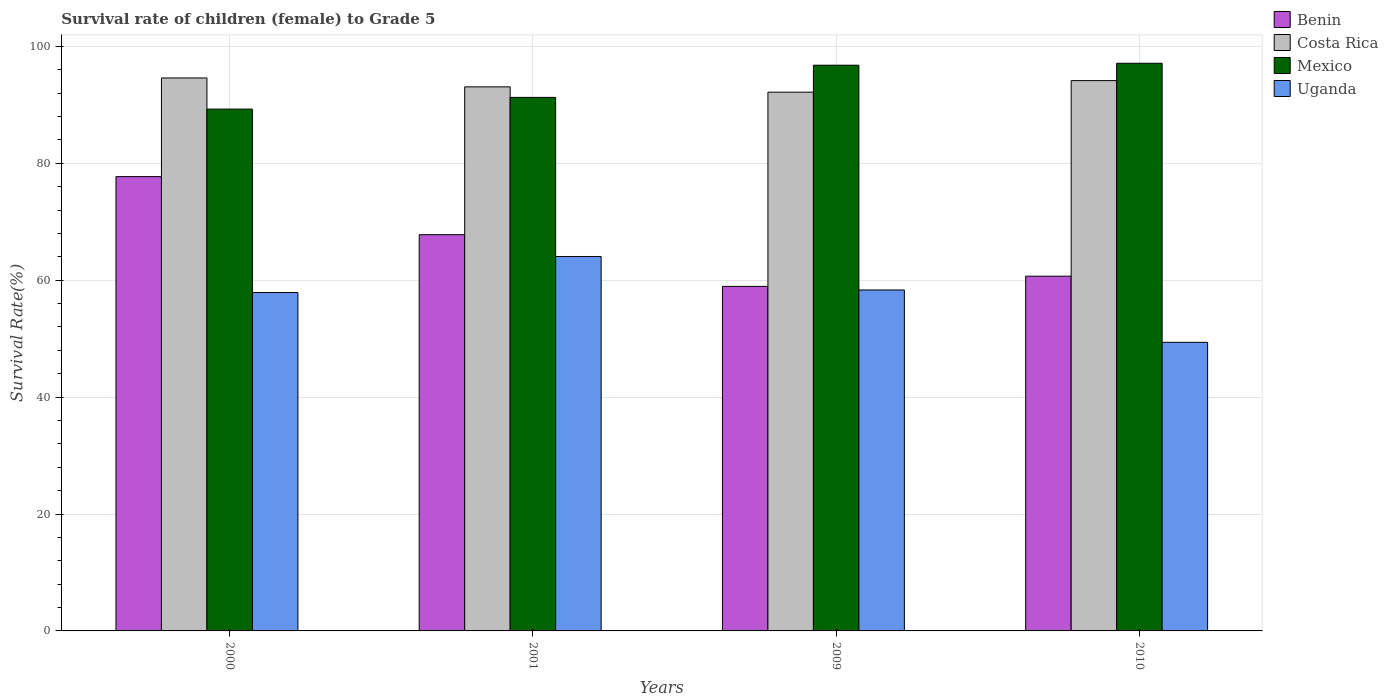How many different coloured bars are there?
Give a very brief answer. 4. How many groups of bars are there?
Your answer should be compact. 4. Are the number of bars per tick equal to the number of legend labels?
Your response must be concise. Yes. Are the number of bars on each tick of the X-axis equal?
Provide a succinct answer. Yes. How many bars are there on the 4th tick from the left?
Provide a short and direct response. 4. What is the label of the 2nd group of bars from the left?
Your response must be concise. 2001. What is the survival rate of female children to grade 5 in Mexico in 2000?
Keep it short and to the point. 89.27. Across all years, what is the maximum survival rate of female children to grade 5 in Benin?
Ensure brevity in your answer.  77.72. Across all years, what is the minimum survival rate of female children to grade 5 in Mexico?
Provide a succinct answer. 89.27. In which year was the survival rate of female children to grade 5 in Costa Rica maximum?
Your response must be concise. 2000. What is the total survival rate of female children to grade 5 in Benin in the graph?
Provide a short and direct response. 265.12. What is the difference between the survival rate of female children to grade 5 in Uganda in 2000 and that in 2010?
Offer a terse response. 8.52. What is the difference between the survival rate of female children to grade 5 in Uganda in 2000 and the survival rate of female children to grade 5 in Mexico in 2009?
Offer a very short reply. -38.88. What is the average survival rate of female children to grade 5 in Uganda per year?
Give a very brief answer. 57.41. In the year 2000, what is the difference between the survival rate of female children to grade 5 in Mexico and survival rate of female children to grade 5 in Uganda?
Your answer should be very brief. 31.37. What is the ratio of the survival rate of female children to grade 5 in Costa Rica in 2009 to that in 2010?
Provide a succinct answer. 0.98. Is the survival rate of female children to grade 5 in Uganda in 2009 less than that in 2010?
Provide a succinct answer. No. What is the difference between the highest and the second highest survival rate of female children to grade 5 in Mexico?
Ensure brevity in your answer.  0.34. What is the difference between the highest and the lowest survival rate of female children to grade 5 in Mexico?
Ensure brevity in your answer.  7.84. What does the 4th bar from the left in 2001 represents?
Your answer should be compact. Uganda. What does the 4th bar from the right in 2010 represents?
Provide a short and direct response. Benin. How many bars are there?
Offer a terse response. 16. Are the values on the major ticks of Y-axis written in scientific E-notation?
Make the answer very short. No. How many legend labels are there?
Make the answer very short. 4. How are the legend labels stacked?
Ensure brevity in your answer.  Vertical. What is the title of the graph?
Provide a short and direct response. Survival rate of children (female) to Grade 5. What is the label or title of the X-axis?
Ensure brevity in your answer.  Years. What is the label or title of the Y-axis?
Provide a succinct answer. Survival Rate(%). What is the Survival Rate(%) of Benin in 2000?
Make the answer very short. 77.72. What is the Survival Rate(%) in Costa Rica in 2000?
Make the answer very short. 94.59. What is the Survival Rate(%) of Mexico in 2000?
Your answer should be very brief. 89.27. What is the Survival Rate(%) of Uganda in 2000?
Provide a succinct answer. 57.89. What is the Survival Rate(%) in Benin in 2001?
Your response must be concise. 67.78. What is the Survival Rate(%) of Costa Rica in 2001?
Your answer should be compact. 93.07. What is the Survival Rate(%) of Mexico in 2001?
Provide a succinct answer. 91.27. What is the Survival Rate(%) in Uganda in 2001?
Make the answer very short. 64.05. What is the Survival Rate(%) of Benin in 2009?
Provide a short and direct response. 58.94. What is the Survival Rate(%) of Costa Rica in 2009?
Your answer should be very brief. 92.16. What is the Survival Rate(%) in Mexico in 2009?
Give a very brief answer. 96.77. What is the Survival Rate(%) of Uganda in 2009?
Ensure brevity in your answer.  58.32. What is the Survival Rate(%) of Benin in 2010?
Keep it short and to the point. 60.68. What is the Survival Rate(%) of Costa Rica in 2010?
Make the answer very short. 94.14. What is the Survival Rate(%) of Mexico in 2010?
Provide a succinct answer. 97.11. What is the Survival Rate(%) of Uganda in 2010?
Your answer should be very brief. 49.37. Across all years, what is the maximum Survival Rate(%) in Benin?
Give a very brief answer. 77.72. Across all years, what is the maximum Survival Rate(%) of Costa Rica?
Your response must be concise. 94.59. Across all years, what is the maximum Survival Rate(%) in Mexico?
Ensure brevity in your answer.  97.11. Across all years, what is the maximum Survival Rate(%) of Uganda?
Provide a succinct answer. 64.05. Across all years, what is the minimum Survival Rate(%) in Benin?
Your answer should be compact. 58.94. Across all years, what is the minimum Survival Rate(%) of Costa Rica?
Offer a very short reply. 92.16. Across all years, what is the minimum Survival Rate(%) in Mexico?
Provide a succinct answer. 89.27. Across all years, what is the minimum Survival Rate(%) in Uganda?
Provide a succinct answer. 49.37. What is the total Survival Rate(%) of Benin in the graph?
Give a very brief answer. 265.12. What is the total Survival Rate(%) in Costa Rica in the graph?
Your answer should be compact. 373.97. What is the total Survival Rate(%) of Mexico in the graph?
Provide a short and direct response. 374.42. What is the total Survival Rate(%) in Uganda in the graph?
Your answer should be compact. 229.64. What is the difference between the Survival Rate(%) in Benin in 2000 and that in 2001?
Make the answer very short. 9.94. What is the difference between the Survival Rate(%) in Costa Rica in 2000 and that in 2001?
Provide a short and direct response. 1.52. What is the difference between the Survival Rate(%) of Mexico in 2000 and that in 2001?
Provide a succinct answer. -2. What is the difference between the Survival Rate(%) of Uganda in 2000 and that in 2001?
Your answer should be very brief. -6.16. What is the difference between the Survival Rate(%) of Benin in 2000 and that in 2009?
Your answer should be very brief. 18.78. What is the difference between the Survival Rate(%) in Costa Rica in 2000 and that in 2009?
Offer a very short reply. 2.43. What is the difference between the Survival Rate(%) of Mexico in 2000 and that in 2009?
Your response must be concise. -7.51. What is the difference between the Survival Rate(%) of Uganda in 2000 and that in 2009?
Your response must be concise. -0.43. What is the difference between the Survival Rate(%) in Benin in 2000 and that in 2010?
Ensure brevity in your answer.  17.03. What is the difference between the Survival Rate(%) of Costa Rica in 2000 and that in 2010?
Your answer should be compact. 0.45. What is the difference between the Survival Rate(%) in Mexico in 2000 and that in 2010?
Make the answer very short. -7.84. What is the difference between the Survival Rate(%) in Uganda in 2000 and that in 2010?
Your answer should be very brief. 8.52. What is the difference between the Survival Rate(%) of Benin in 2001 and that in 2009?
Keep it short and to the point. 8.84. What is the difference between the Survival Rate(%) of Costa Rica in 2001 and that in 2009?
Provide a succinct answer. 0.91. What is the difference between the Survival Rate(%) of Mexico in 2001 and that in 2009?
Your response must be concise. -5.5. What is the difference between the Survival Rate(%) of Uganda in 2001 and that in 2009?
Offer a terse response. 5.73. What is the difference between the Survival Rate(%) of Benin in 2001 and that in 2010?
Provide a short and direct response. 7.1. What is the difference between the Survival Rate(%) of Costa Rica in 2001 and that in 2010?
Provide a succinct answer. -1.07. What is the difference between the Survival Rate(%) of Mexico in 2001 and that in 2010?
Offer a very short reply. -5.84. What is the difference between the Survival Rate(%) in Uganda in 2001 and that in 2010?
Provide a succinct answer. 14.68. What is the difference between the Survival Rate(%) of Benin in 2009 and that in 2010?
Provide a short and direct response. -1.75. What is the difference between the Survival Rate(%) in Costa Rica in 2009 and that in 2010?
Your answer should be compact. -1.98. What is the difference between the Survival Rate(%) of Mexico in 2009 and that in 2010?
Provide a short and direct response. -0.34. What is the difference between the Survival Rate(%) of Uganda in 2009 and that in 2010?
Your answer should be very brief. 8.95. What is the difference between the Survival Rate(%) in Benin in 2000 and the Survival Rate(%) in Costa Rica in 2001?
Ensure brevity in your answer.  -15.36. What is the difference between the Survival Rate(%) of Benin in 2000 and the Survival Rate(%) of Mexico in 2001?
Keep it short and to the point. -13.55. What is the difference between the Survival Rate(%) of Benin in 2000 and the Survival Rate(%) of Uganda in 2001?
Give a very brief answer. 13.66. What is the difference between the Survival Rate(%) in Costa Rica in 2000 and the Survival Rate(%) in Mexico in 2001?
Provide a short and direct response. 3.33. What is the difference between the Survival Rate(%) of Costa Rica in 2000 and the Survival Rate(%) of Uganda in 2001?
Your answer should be very brief. 30.54. What is the difference between the Survival Rate(%) in Mexico in 2000 and the Survival Rate(%) in Uganda in 2001?
Keep it short and to the point. 25.21. What is the difference between the Survival Rate(%) in Benin in 2000 and the Survival Rate(%) in Costa Rica in 2009?
Provide a short and direct response. -14.45. What is the difference between the Survival Rate(%) of Benin in 2000 and the Survival Rate(%) of Mexico in 2009?
Offer a terse response. -19.06. What is the difference between the Survival Rate(%) in Benin in 2000 and the Survival Rate(%) in Uganda in 2009?
Make the answer very short. 19.39. What is the difference between the Survival Rate(%) of Costa Rica in 2000 and the Survival Rate(%) of Mexico in 2009?
Offer a very short reply. -2.18. What is the difference between the Survival Rate(%) in Costa Rica in 2000 and the Survival Rate(%) in Uganda in 2009?
Make the answer very short. 36.27. What is the difference between the Survival Rate(%) of Mexico in 2000 and the Survival Rate(%) of Uganda in 2009?
Make the answer very short. 30.94. What is the difference between the Survival Rate(%) of Benin in 2000 and the Survival Rate(%) of Costa Rica in 2010?
Provide a succinct answer. -16.42. What is the difference between the Survival Rate(%) of Benin in 2000 and the Survival Rate(%) of Mexico in 2010?
Offer a terse response. -19.39. What is the difference between the Survival Rate(%) in Benin in 2000 and the Survival Rate(%) in Uganda in 2010?
Provide a short and direct response. 28.35. What is the difference between the Survival Rate(%) in Costa Rica in 2000 and the Survival Rate(%) in Mexico in 2010?
Your answer should be compact. -2.52. What is the difference between the Survival Rate(%) in Costa Rica in 2000 and the Survival Rate(%) in Uganda in 2010?
Make the answer very short. 45.22. What is the difference between the Survival Rate(%) in Mexico in 2000 and the Survival Rate(%) in Uganda in 2010?
Offer a very short reply. 39.9. What is the difference between the Survival Rate(%) in Benin in 2001 and the Survival Rate(%) in Costa Rica in 2009?
Keep it short and to the point. -24.38. What is the difference between the Survival Rate(%) of Benin in 2001 and the Survival Rate(%) of Mexico in 2009?
Offer a very short reply. -28.99. What is the difference between the Survival Rate(%) of Benin in 2001 and the Survival Rate(%) of Uganda in 2009?
Keep it short and to the point. 9.46. What is the difference between the Survival Rate(%) of Costa Rica in 2001 and the Survival Rate(%) of Mexico in 2009?
Your response must be concise. -3.7. What is the difference between the Survival Rate(%) of Costa Rica in 2001 and the Survival Rate(%) of Uganda in 2009?
Your answer should be very brief. 34.75. What is the difference between the Survival Rate(%) of Mexico in 2001 and the Survival Rate(%) of Uganda in 2009?
Offer a very short reply. 32.95. What is the difference between the Survival Rate(%) of Benin in 2001 and the Survival Rate(%) of Costa Rica in 2010?
Keep it short and to the point. -26.36. What is the difference between the Survival Rate(%) of Benin in 2001 and the Survival Rate(%) of Mexico in 2010?
Give a very brief answer. -29.33. What is the difference between the Survival Rate(%) in Benin in 2001 and the Survival Rate(%) in Uganda in 2010?
Your answer should be very brief. 18.41. What is the difference between the Survival Rate(%) of Costa Rica in 2001 and the Survival Rate(%) of Mexico in 2010?
Your answer should be compact. -4.04. What is the difference between the Survival Rate(%) in Costa Rica in 2001 and the Survival Rate(%) in Uganda in 2010?
Your response must be concise. 43.7. What is the difference between the Survival Rate(%) of Mexico in 2001 and the Survival Rate(%) of Uganda in 2010?
Make the answer very short. 41.9. What is the difference between the Survival Rate(%) in Benin in 2009 and the Survival Rate(%) in Costa Rica in 2010?
Keep it short and to the point. -35.2. What is the difference between the Survival Rate(%) of Benin in 2009 and the Survival Rate(%) of Mexico in 2010?
Keep it short and to the point. -38.17. What is the difference between the Survival Rate(%) in Benin in 2009 and the Survival Rate(%) in Uganda in 2010?
Give a very brief answer. 9.57. What is the difference between the Survival Rate(%) of Costa Rica in 2009 and the Survival Rate(%) of Mexico in 2010?
Offer a very short reply. -4.95. What is the difference between the Survival Rate(%) in Costa Rica in 2009 and the Survival Rate(%) in Uganda in 2010?
Offer a very short reply. 42.79. What is the difference between the Survival Rate(%) of Mexico in 2009 and the Survival Rate(%) of Uganda in 2010?
Your answer should be very brief. 47.4. What is the average Survival Rate(%) in Benin per year?
Ensure brevity in your answer.  66.28. What is the average Survival Rate(%) of Costa Rica per year?
Provide a succinct answer. 93.49. What is the average Survival Rate(%) in Mexico per year?
Your answer should be very brief. 93.6. What is the average Survival Rate(%) in Uganda per year?
Ensure brevity in your answer.  57.41. In the year 2000, what is the difference between the Survival Rate(%) of Benin and Survival Rate(%) of Costa Rica?
Provide a short and direct response. -16.88. In the year 2000, what is the difference between the Survival Rate(%) in Benin and Survival Rate(%) in Mexico?
Provide a succinct answer. -11.55. In the year 2000, what is the difference between the Survival Rate(%) in Benin and Survival Rate(%) in Uganda?
Offer a terse response. 19.82. In the year 2000, what is the difference between the Survival Rate(%) of Costa Rica and Survival Rate(%) of Mexico?
Keep it short and to the point. 5.33. In the year 2000, what is the difference between the Survival Rate(%) in Costa Rica and Survival Rate(%) in Uganda?
Offer a very short reply. 36.7. In the year 2000, what is the difference between the Survival Rate(%) of Mexico and Survival Rate(%) of Uganda?
Ensure brevity in your answer.  31.37. In the year 2001, what is the difference between the Survival Rate(%) of Benin and Survival Rate(%) of Costa Rica?
Provide a succinct answer. -25.29. In the year 2001, what is the difference between the Survival Rate(%) of Benin and Survival Rate(%) of Mexico?
Make the answer very short. -23.49. In the year 2001, what is the difference between the Survival Rate(%) of Benin and Survival Rate(%) of Uganda?
Give a very brief answer. 3.73. In the year 2001, what is the difference between the Survival Rate(%) of Costa Rica and Survival Rate(%) of Mexico?
Your answer should be very brief. 1.8. In the year 2001, what is the difference between the Survival Rate(%) of Costa Rica and Survival Rate(%) of Uganda?
Your answer should be compact. 29.02. In the year 2001, what is the difference between the Survival Rate(%) in Mexico and Survival Rate(%) in Uganda?
Offer a terse response. 27.22. In the year 2009, what is the difference between the Survival Rate(%) of Benin and Survival Rate(%) of Costa Rica?
Your response must be concise. -33.22. In the year 2009, what is the difference between the Survival Rate(%) in Benin and Survival Rate(%) in Mexico?
Your answer should be very brief. -37.83. In the year 2009, what is the difference between the Survival Rate(%) in Benin and Survival Rate(%) in Uganda?
Provide a succinct answer. 0.61. In the year 2009, what is the difference between the Survival Rate(%) of Costa Rica and Survival Rate(%) of Mexico?
Give a very brief answer. -4.61. In the year 2009, what is the difference between the Survival Rate(%) in Costa Rica and Survival Rate(%) in Uganda?
Your response must be concise. 33.84. In the year 2009, what is the difference between the Survival Rate(%) in Mexico and Survival Rate(%) in Uganda?
Your answer should be compact. 38.45. In the year 2010, what is the difference between the Survival Rate(%) of Benin and Survival Rate(%) of Costa Rica?
Offer a terse response. -33.45. In the year 2010, what is the difference between the Survival Rate(%) of Benin and Survival Rate(%) of Mexico?
Provide a short and direct response. -36.42. In the year 2010, what is the difference between the Survival Rate(%) in Benin and Survival Rate(%) in Uganda?
Provide a succinct answer. 11.31. In the year 2010, what is the difference between the Survival Rate(%) of Costa Rica and Survival Rate(%) of Mexico?
Give a very brief answer. -2.97. In the year 2010, what is the difference between the Survival Rate(%) in Costa Rica and Survival Rate(%) in Uganda?
Your response must be concise. 44.77. In the year 2010, what is the difference between the Survival Rate(%) in Mexico and Survival Rate(%) in Uganda?
Your answer should be compact. 47.74. What is the ratio of the Survival Rate(%) of Benin in 2000 to that in 2001?
Provide a short and direct response. 1.15. What is the ratio of the Survival Rate(%) in Costa Rica in 2000 to that in 2001?
Offer a terse response. 1.02. What is the ratio of the Survival Rate(%) of Mexico in 2000 to that in 2001?
Provide a short and direct response. 0.98. What is the ratio of the Survival Rate(%) of Uganda in 2000 to that in 2001?
Provide a succinct answer. 0.9. What is the ratio of the Survival Rate(%) in Benin in 2000 to that in 2009?
Offer a very short reply. 1.32. What is the ratio of the Survival Rate(%) of Costa Rica in 2000 to that in 2009?
Keep it short and to the point. 1.03. What is the ratio of the Survival Rate(%) in Mexico in 2000 to that in 2009?
Give a very brief answer. 0.92. What is the ratio of the Survival Rate(%) in Uganda in 2000 to that in 2009?
Offer a terse response. 0.99. What is the ratio of the Survival Rate(%) of Benin in 2000 to that in 2010?
Your answer should be compact. 1.28. What is the ratio of the Survival Rate(%) in Mexico in 2000 to that in 2010?
Give a very brief answer. 0.92. What is the ratio of the Survival Rate(%) in Uganda in 2000 to that in 2010?
Your answer should be compact. 1.17. What is the ratio of the Survival Rate(%) of Benin in 2001 to that in 2009?
Give a very brief answer. 1.15. What is the ratio of the Survival Rate(%) in Costa Rica in 2001 to that in 2009?
Provide a succinct answer. 1.01. What is the ratio of the Survival Rate(%) in Mexico in 2001 to that in 2009?
Make the answer very short. 0.94. What is the ratio of the Survival Rate(%) of Uganda in 2001 to that in 2009?
Offer a very short reply. 1.1. What is the ratio of the Survival Rate(%) of Benin in 2001 to that in 2010?
Your answer should be compact. 1.12. What is the ratio of the Survival Rate(%) in Costa Rica in 2001 to that in 2010?
Provide a succinct answer. 0.99. What is the ratio of the Survival Rate(%) of Mexico in 2001 to that in 2010?
Ensure brevity in your answer.  0.94. What is the ratio of the Survival Rate(%) of Uganda in 2001 to that in 2010?
Give a very brief answer. 1.3. What is the ratio of the Survival Rate(%) of Benin in 2009 to that in 2010?
Give a very brief answer. 0.97. What is the ratio of the Survival Rate(%) in Costa Rica in 2009 to that in 2010?
Your response must be concise. 0.98. What is the ratio of the Survival Rate(%) of Mexico in 2009 to that in 2010?
Give a very brief answer. 1. What is the ratio of the Survival Rate(%) of Uganda in 2009 to that in 2010?
Provide a short and direct response. 1.18. What is the difference between the highest and the second highest Survival Rate(%) in Benin?
Offer a very short reply. 9.94. What is the difference between the highest and the second highest Survival Rate(%) of Costa Rica?
Provide a succinct answer. 0.45. What is the difference between the highest and the second highest Survival Rate(%) in Mexico?
Offer a terse response. 0.34. What is the difference between the highest and the second highest Survival Rate(%) in Uganda?
Your answer should be compact. 5.73. What is the difference between the highest and the lowest Survival Rate(%) in Benin?
Provide a succinct answer. 18.78. What is the difference between the highest and the lowest Survival Rate(%) in Costa Rica?
Provide a short and direct response. 2.43. What is the difference between the highest and the lowest Survival Rate(%) of Mexico?
Keep it short and to the point. 7.84. What is the difference between the highest and the lowest Survival Rate(%) of Uganda?
Provide a succinct answer. 14.68. 